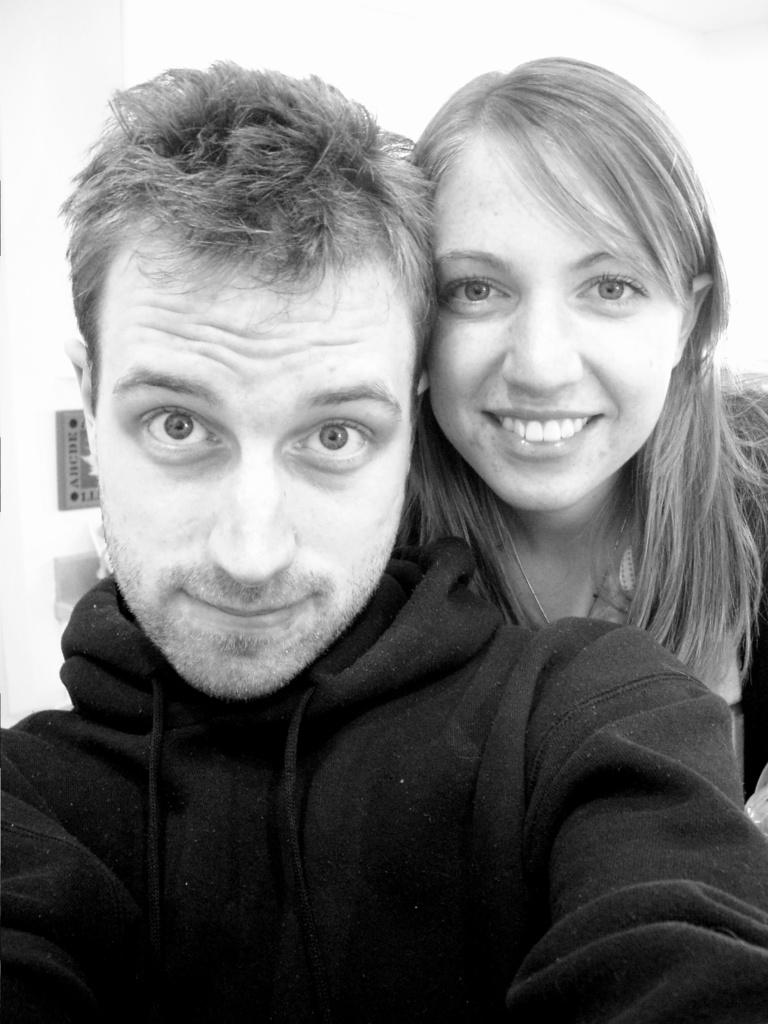Who are the people in the image? There is a man and a woman in the image. What is the woman doing in the image? The woman is smiling in the image. What is the man wearing in the image? The man is wearing a black color jacket in the image. How many patches can be seen on the man's jacket in the image? There are no patches visible on the man's jacket in the image; it is described as a black color jacket. What type of force is being applied by the woman in the image? There is no indication of any force being applied by the woman in the image; she is simply smiling. 